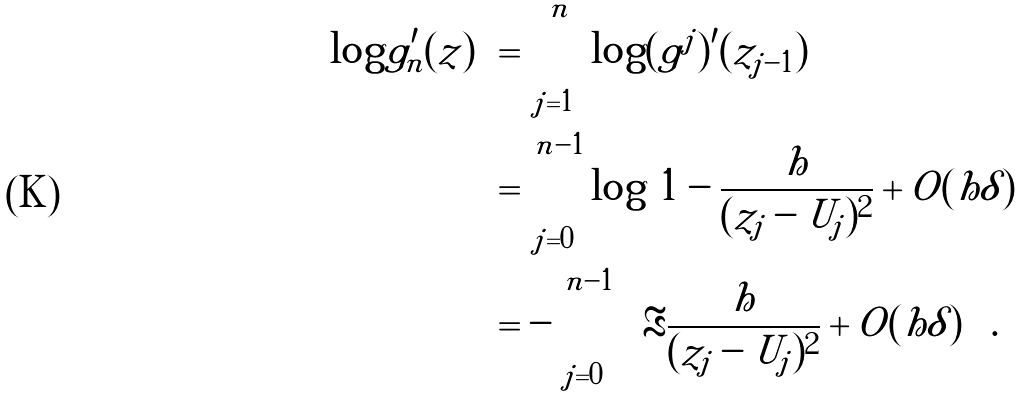<formula> <loc_0><loc_0><loc_500><loc_500>\log | g ^ { \prime } _ { n } ( z ) | & = \sum _ { j = 1 } ^ { n } \log | ( g ^ { j } ) ^ { \prime } ( z _ { j - 1 } ) | \\ & = \sum _ { j = 0 } ^ { n - 1 } \log \left | 1 - \frac { h } { ( z _ { j } - U _ { j } ) ^ { 2 } } + O ( h \delta ) \right | \\ & = - \sum _ { j = 0 } ^ { n - 1 } \left ( \Re \frac { h } { ( z _ { j } - U _ { j } ) ^ { 2 } } + O ( h \delta ) \right ) .</formula> 